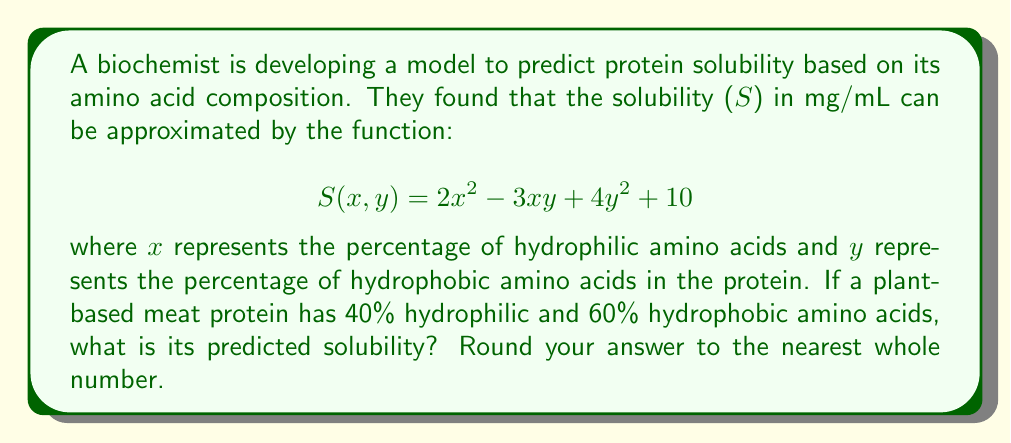Can you answer this question? To solve this problem, we need to follow these steps:

1. Identify the given values:
   x = 40% = 0.40 (hydrophilic amino acids)
   y = 60% = 0.60 (hydrophobic amino acids)

2. Substitute these values into the solubility function:
   $$S(0.40, 0.60) = 2(0.40)^2 - 3(0.40)(0.60) + 4(0.60)^2 + 10$$

3. Calculate each term:
   - $2(0.40)^2 = 2(0.16) = 0.32$
   - $-3(0.40)(0.60) = -0.72$
   - $4(0.60)^2 = 4(0.36) = 1.44$
   - The constant term is 10

4. Sum up all the terms:
   $$S(0.40, 0.60) = 0.32 - 0.72 + 1.44 + 10 = 11.04$$

5. Round to the nearest whole number:
   11.04 rounds to 11 mg/mL

Therefore, the predicted solubility of the plant-based meat protein is 11 mg/mL.
Answer: 11 mg/mL 